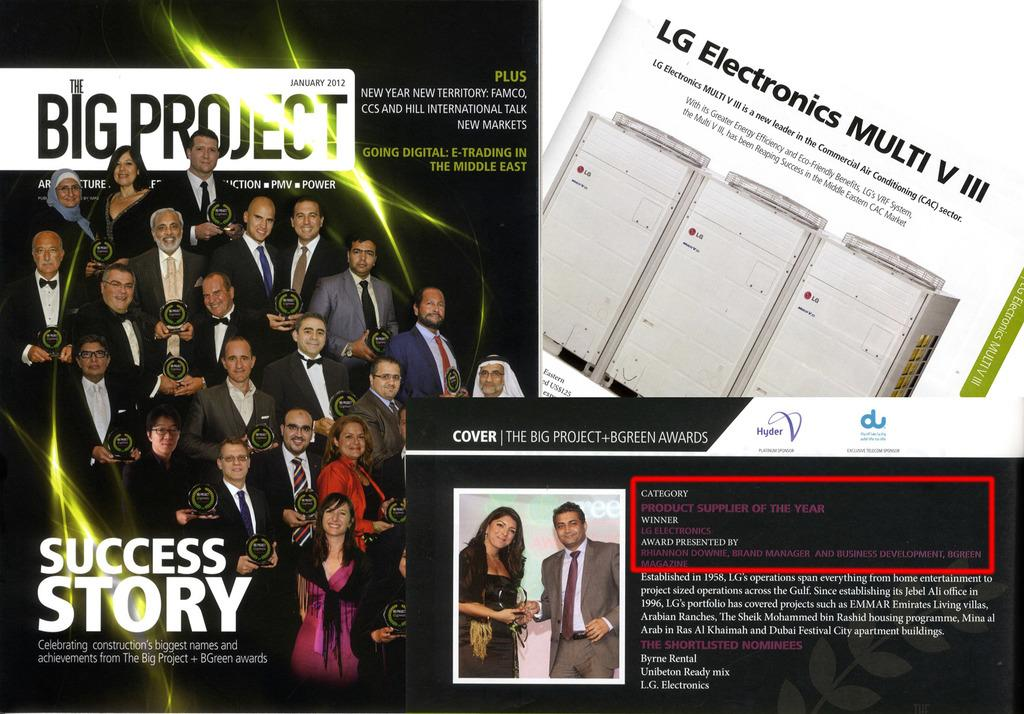<image>
Present a compact description of the photo's key features. an ad title success stories featuring people holding awards 